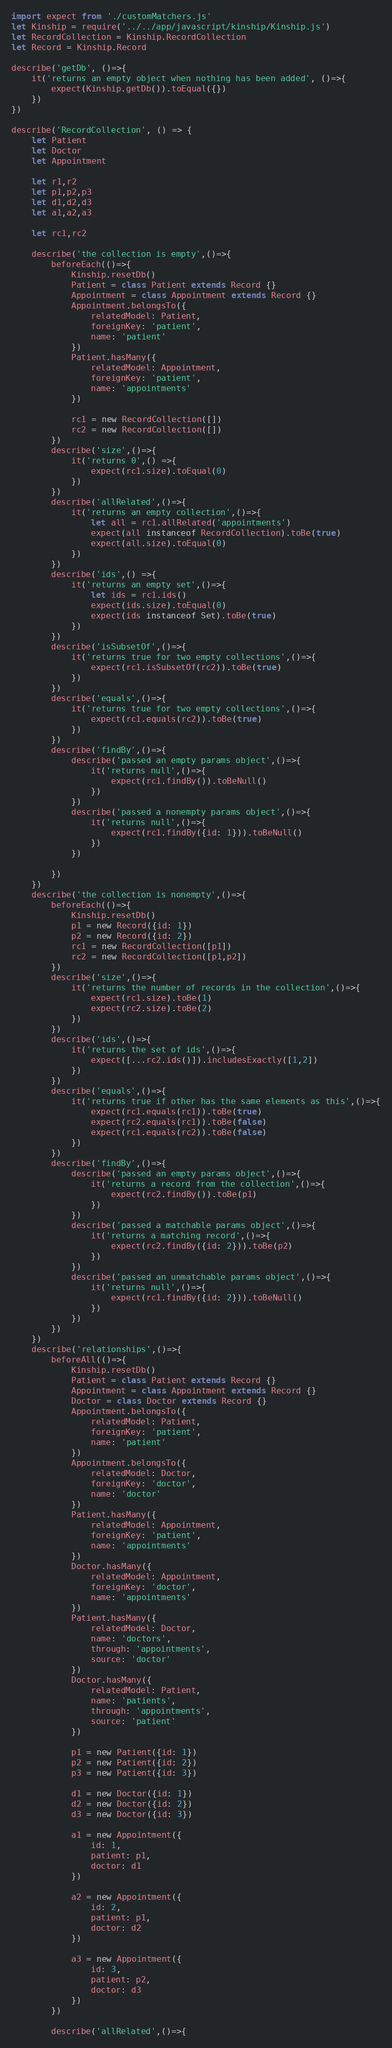<code> <loc_0><loc_0><loc_500><loc_500><_JavaScript_>import expect from './customMatchers.js'
let Kinship = require('../../app/javascript/kinship/Kinship.js')
let RecordCollection = Kinship.RecordCollection
let Record = Kinship.Record

describe('getDb', ()=>{
	it('returns an empty object when nothing has been added', ()=>{
		expect(Kinship.getDb()).toEqual({})
	})
})

describe('RecordCollection', () => {
	let Patient
	let Doctor
	let Appointment

	let r1,r2
	let p1,p2,p3
	let d1,d2,d3
	let a1,a2,a3

	let rc1,rc2

	describe('the collection is empty',()=>{
		beforeEach(()=>{
			Kinship.resetDb()
			Patient = class Patient extends Record {}
			Appointment = class Appointment extends Record {}
			Appointment.belongsTo({
				relatedModel: Patient,
				foreignKey: 'patient',
				name: 'patient'
			})
			Patient.hasMany({
				relatedModel: Appointment,
				foreignKey: 'patient',
				name: 'appointments'
			})

			rc1 = new RecordCollection([])
			rc2 = new RecordCollection([])
		})
		describe('size',()=>{
			it('returns 0',() =>{
				expect(rc1.size).toEqual(0)	
			})	
		})
		describe('allRelated',()=>{
			it('returns an empty collection',()=>{
				let all = rc1.allRelated('appointments')
				expect(all instanceof RecordCollection).toBe(true)
				expect(all.size).toEqual(0)
			})
		})
		describe('ids',() =>{
			it('returns an empty set',()=>{
				let ids = rc1.ids()
				expect(ids.size).toEqual(0)
				expect(ids instanceof Set).toBe(true)
			})
		})
		describe('isSubsetOf',()=>{
			it('returns true for two empty collections',()=>{
				expect(rc1.isSubsetOf(rc2)).toBe(true)
			})
		})
		describe('equals',()=>{
			it('returns true for two empty collections',()=>{
				expect(rc1.equals(rc2)).toBe(true)
			})
		})
		describe('findBy',()=>{
			describe('passed an empty params object',()=>{
				it('returns null',()=>{
					expect(rc1.findBy()).toBeNull()
				})	
			})
			describe('passed a nonempty params object',()=>{
				it('returns null',()=>{
					expect(rc1.findBy({id: 1})).toBeNull()
				})
			})
			
		})
	})
	describe('the collection is nonempty',()=>{
		beforeEach(()=>{
			Kinship.resetDb()
			p1 = new Record({id: 1})
			p2 = new Record({id: 2})
			rc1 = new RecordCollection([p1])
			rc2 = new RecordCollection([p1,p2])
		})
		describe('size',()=>{
			it('returns the number of records in the collection',()=>{
				expect(rc1.size).toBe(1)
				expect(rc2.size).toBe(2)
			})
		})
		describe('ids',()=>{
			it('returns the set of ids',()=>{
				expect([...rc2.ids()]).includesExactly([1,2])
			})
		})
		describe('equals',()=>{
			it('returns true if other has the same elements as this',()=>{
				expect(rc1.equals(rc1)).toBe(true)
				expect(rc2.equals(rc1)).toBe(false)
				expect(rc1.equals(rc2)).toBe(false)
			})
		})
		describe('findBy',()=>{
			describe('passed an empty params object',()=>{
				it('returns a record from the collection',()=>{
					expect(rc2.findBy()).toBe(p1)
				})	
			})
			describe('passed a matchable params object',()=>{
				it('returns a matching record',()=>{
					expect(rc2.findBy({id: 2})).toBe(p2)
				})
			})
			describe('passed an unmatchable params object',()=>{
				it('returns null',()=>{
					expect(rc1.findBy({id: 2})).toBeNull()
				})
			})
		})
	})
	describe('relationships',()=>{
		beforeAll(()=>{
			Kinship.resetDb()
			Patient = class Patient extends Record {}
			Appointment = class Appointment extends Record {}
			Doctor = class Doctor extends Record {}
			Appointment.belongsTo({
				relatedModel: Patient,
				foreignKey: 'patient',
				name: 'patient'
			})
			Appointment.belongsTo({
				relatedModel: Doctor,
				foreignKey: 'doctor',
				name: 'doctor'
			})
			Patient.hasMany({
				relatedModel: Appointment,
				foreignKey: 'patient',
				name: 'appointments'
			})
			Doctor.hasMany({
				relatedModel: Appointment,
				foreignKey: 'doctor',
				name: 'appointments'
			})
			Patient.hasMany({
				relatedModel: Doctor,
				name: 'doctors',
				through: 'appointments',
				source: 'doctor'
			})
			Doctor.hasMany({
				relatedModel: Patient,
				name: 'patients',
				through: 'appointments',
				source: 'patient'
			})

			p1 = new Patient({id: 1})
			p2 = new Patient({id: 2})
			p3 = new Patient({id: 3})

			d1 = new Doctor({id: 1})
			d2 = new Doctor({id: 2})
			d3 = new Doctor({id: 3})

			a1 = new Appointment({
				id: 1,
				patient: p1,
				doctor: d1
			})

			a2 = new Appointment({
				id: 2,
				patient: p1,
				doctor: d2
			})

			a3 = new Appointment({
				id: 3,
				patient: p2,
				doctor: d3
			})
		})

		describe('allRelated',()=>{</code> 